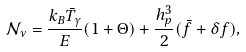Convert formula to latex. <formula><loc_0><loc_0><loc_500><loc_500>\mathcal { N } _ { \nu } = \frac { k _ { B } \bar { T } _ { \gamma } } { E } ( 1 + \Theta ) + \frac { h _ { p } ^ { 3 } } { 2 } ( \bar { f } + \delta f ) ,</formula> 